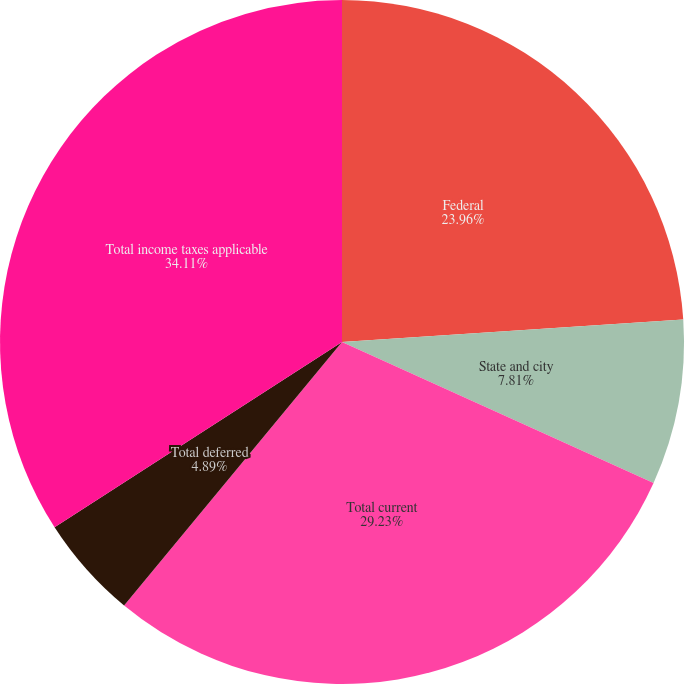Convert chart to OTSL. <chart><loc_0><loc_0><loc_500><loc_500><pie_chart><fcel>Federal<fcel>State and city<fcel>Total current<fcel>Total deferred<fcel>Total income taxes applicable<nl><fcel>23.96%<fcel>7.81%<fcel>29.23%<fcel>4.89%<fcel>34.12%<nl></chart> 